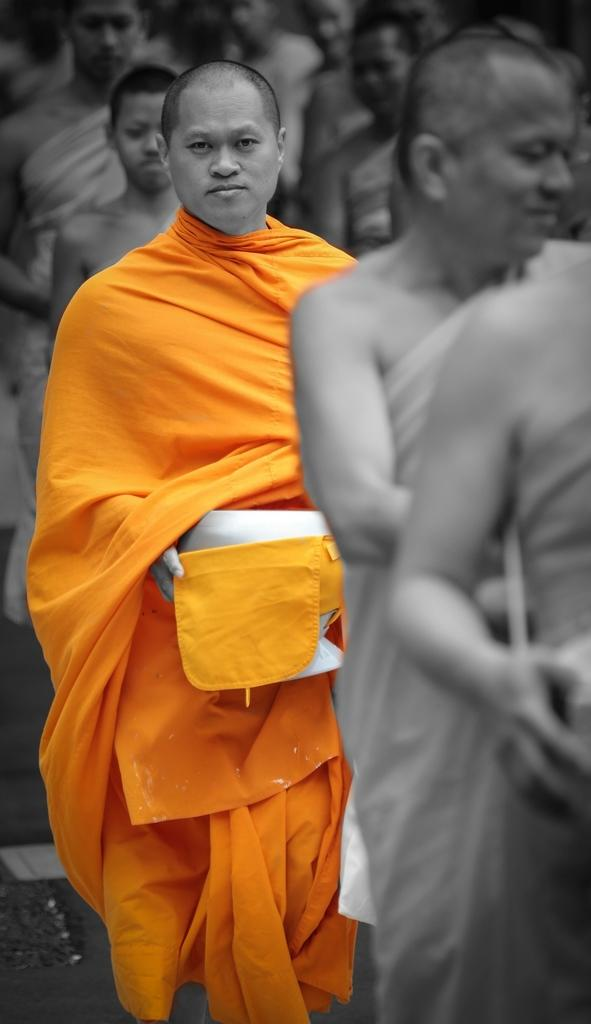What is the color scheme of the image? The image is black and white. Is there any color used to highlight any element in the image? Yes, one person is highlighted with color in the image. What type of treatment is the person receiving in the image? There is no indication of any treatment being administered in the image, as it is a black and white image with one person highlighted in color. 